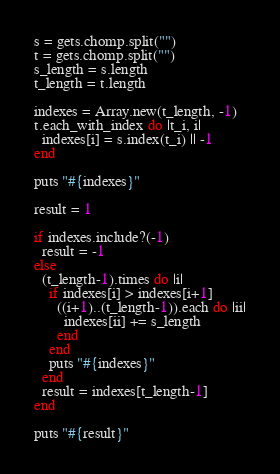Convert code to text. <code><loc_0><loc_0><loc_500><loc_500><_Ruby_>s = gets.chomp.split("")
t = gets.chomp.split("")
s_length = s.length
t_length = t.length

indexes = Array.new(t_length, -1)
t.each_with_index do |t_i, i|
  indexes[i] = s.index(t_i) || -1
end

puts "#{indexes}"

result = 1

if indexes.include?(-1)
  result = -1
else
  (t_length-1).times do |i|
    if indexes[i] > indexes[i+1]
      ((i+1)..(t_length-1)).each do |ii|
        indexes[ii] += s_length
      end
    end
    puts "#{indexes}"
  end
  result = indexes[t_length-1]
end

puts "#{result}"</code> 